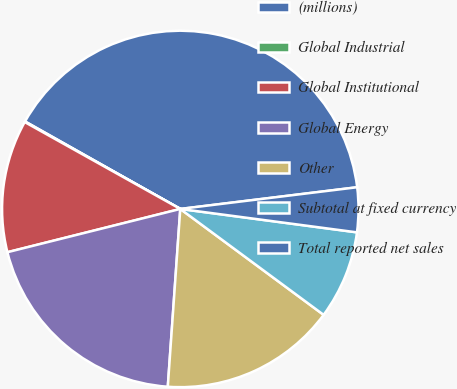Convert chart to OTSL. <chart><loc_0><loc_0><loc_500><loc_500><pie_chart><fcel>(millions)<fcel>Global Industrial<fcel>Global Institutional<fcel>Global Energy<fcel>Other<fcel>Subtotal at fixed currency<fcel>Total reported net sales<nl><fcel>39.89%<fcel>0.06%<fcel>12.01%<fcel>19.98%<fcel>15.99%<fcel>8.03%<fcel>4.04%<nl></chart> 